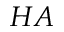<formula> <loc_0><loc_0><loc_500><loc_500>H A</formula> 